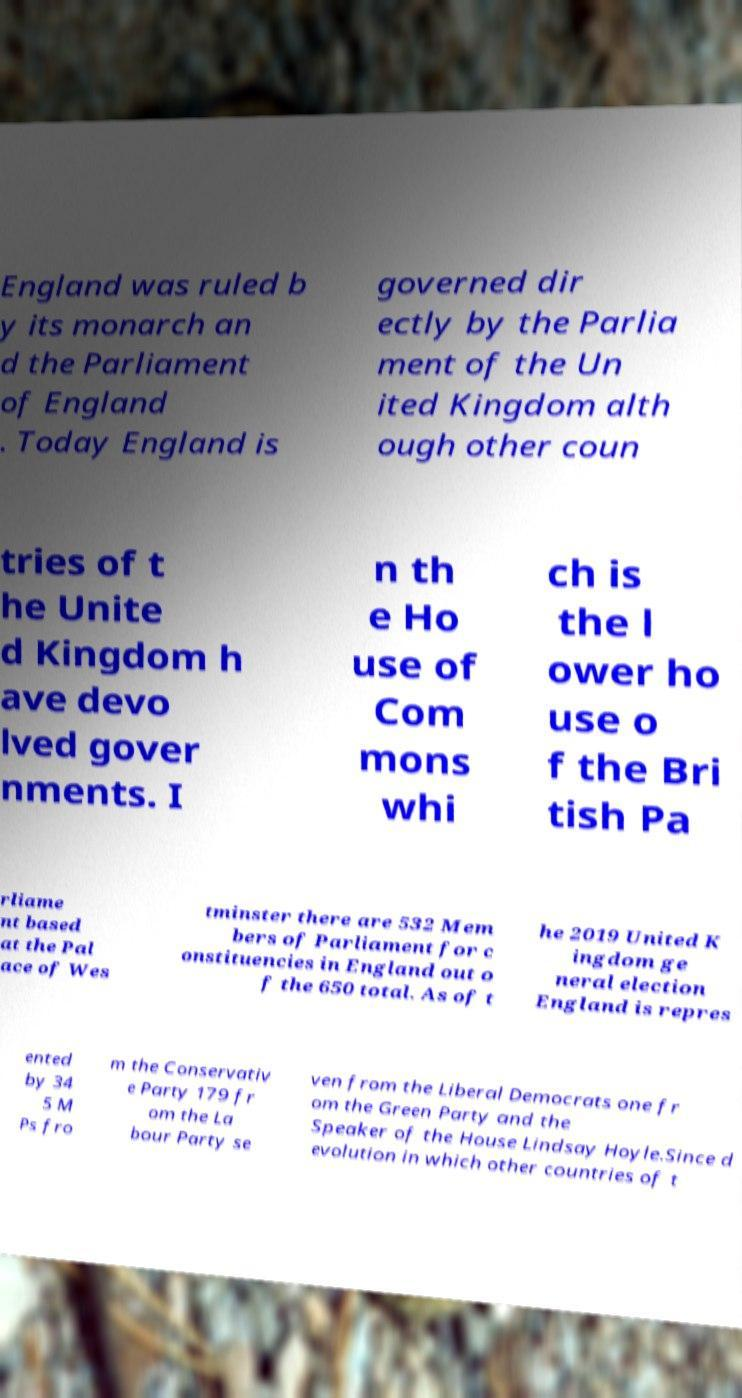Can you accurately transcribe the text from the provided image for me? England was ruled b y its monarch an d the Parliament of England . Today England is governed dir ectly by the Parlia ment of the Un ited Kingdom alth ough other coun tries of t he Unite d Kingdom h ave devo lved gover nments. I n th e Ho use of Com mons whi ch is the l ower ho use o f the Bri tish Pa rliame nt based at the Pal ace of Wes tminster there are 532 Mem bers of Parliament for c onstituencies in England out o f the 650 total. As of t he 2019 United K ingdom ge neral election England is repres ented by 34 5 M Ps fro m the Conservativ e Party 179 fr om the La bour Party se ven from the Liberal Democrats one fr om the Green Party and the Speaker of the House Lindsay Hoyle.Since d evolution in which other countries of t 